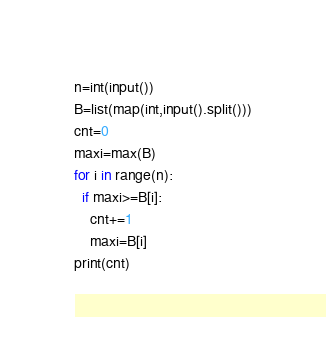<code> <loc_0><loc_0><loc_500><loc_500><_Python_>n=int(input())
B=list(map(int,input().split()))
cnt=0
maxi=max(B)
for i in range(n):
  if maxi>=B[i]:
    cnt+=1
    maxi=B[i]
print(cnt)</code> 